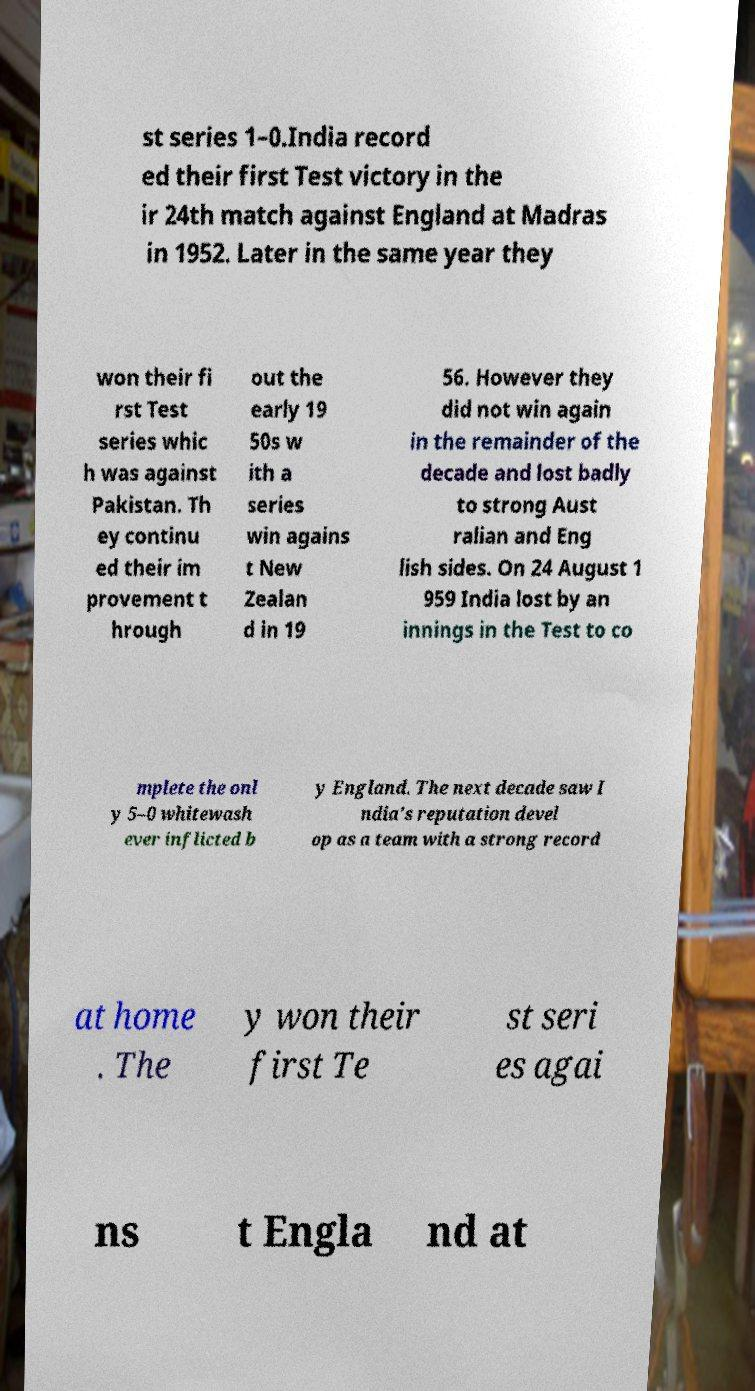Please read and relay the text visible in this image. What does it say? st series 1–0.India record ed their first Test victory in the ir 24th match against England at Madras in 1952. Later in the same year they won their fi rst Test series whic h was against Pakistan. Th ey continu ed their im provement t hrough out the early 19 50s w ith a series win agains t New Zealan d in 19 56. However they did not win again in the remainder of the decade and lost badly to strong Aust ralian and Eng lish sides. On 24 August 1 959 India lost by an innings in the Test to co mplete the onl y 5–0 whitewash ever inflicted b y England. The next decade saw I ndia's reputation devel op as a team with a strong record at home . The y won their first Te st seri es agai ns t Engla nd at 